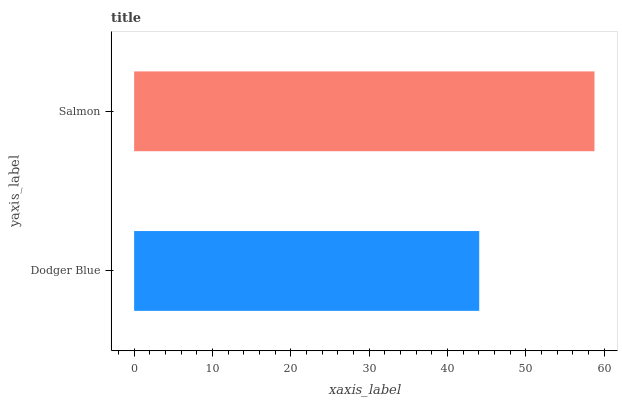Is Dodger Blue the minimum?
Answer yes or no. Yes. Is Salmon the maximum?
Answer yes or no. Yes. Is Salmon the minimum?
Answer yes or no. No. Is Salmon greater than Dodger Blue?
Answer yes or no. Yes. Is Dodger Blue less than Salmon?
Answer yes or no. Yes. Is Dodger Blue greater than Salmon?
Answer yes or no. No. Is Salmon less than Dodger Blue?
Answer yes or no. No. Is Salmon the high median?
Answer yes or no. Yes. Is Dodger Blue the low median?
Answer yes or no. Yes. Is Dodger Blue the high median?
Answer yes or no. No. Is Salmon the low median?
Answer yes or no. No. 